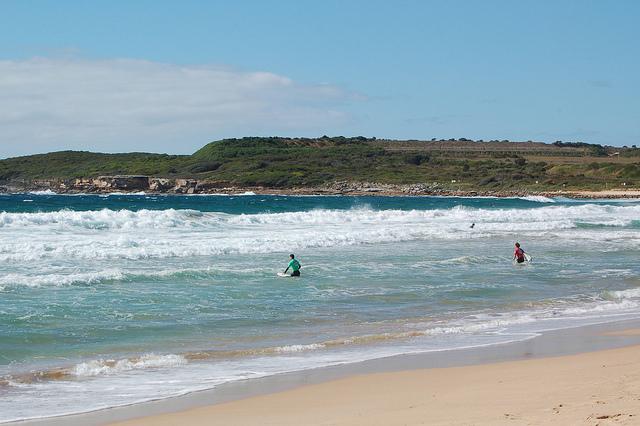Are the surfers walking into the water?
Give a very brief answer. Yes. Where was this pic taken?
Answer briefly. Beach. Is this a private location?
Give a very brief answer. No. Where is the surfboard?
Short answer required. Water. What powers the sail?
Write a very short answer. Wind. How many people are in the water?
Concise answer only. 2. 